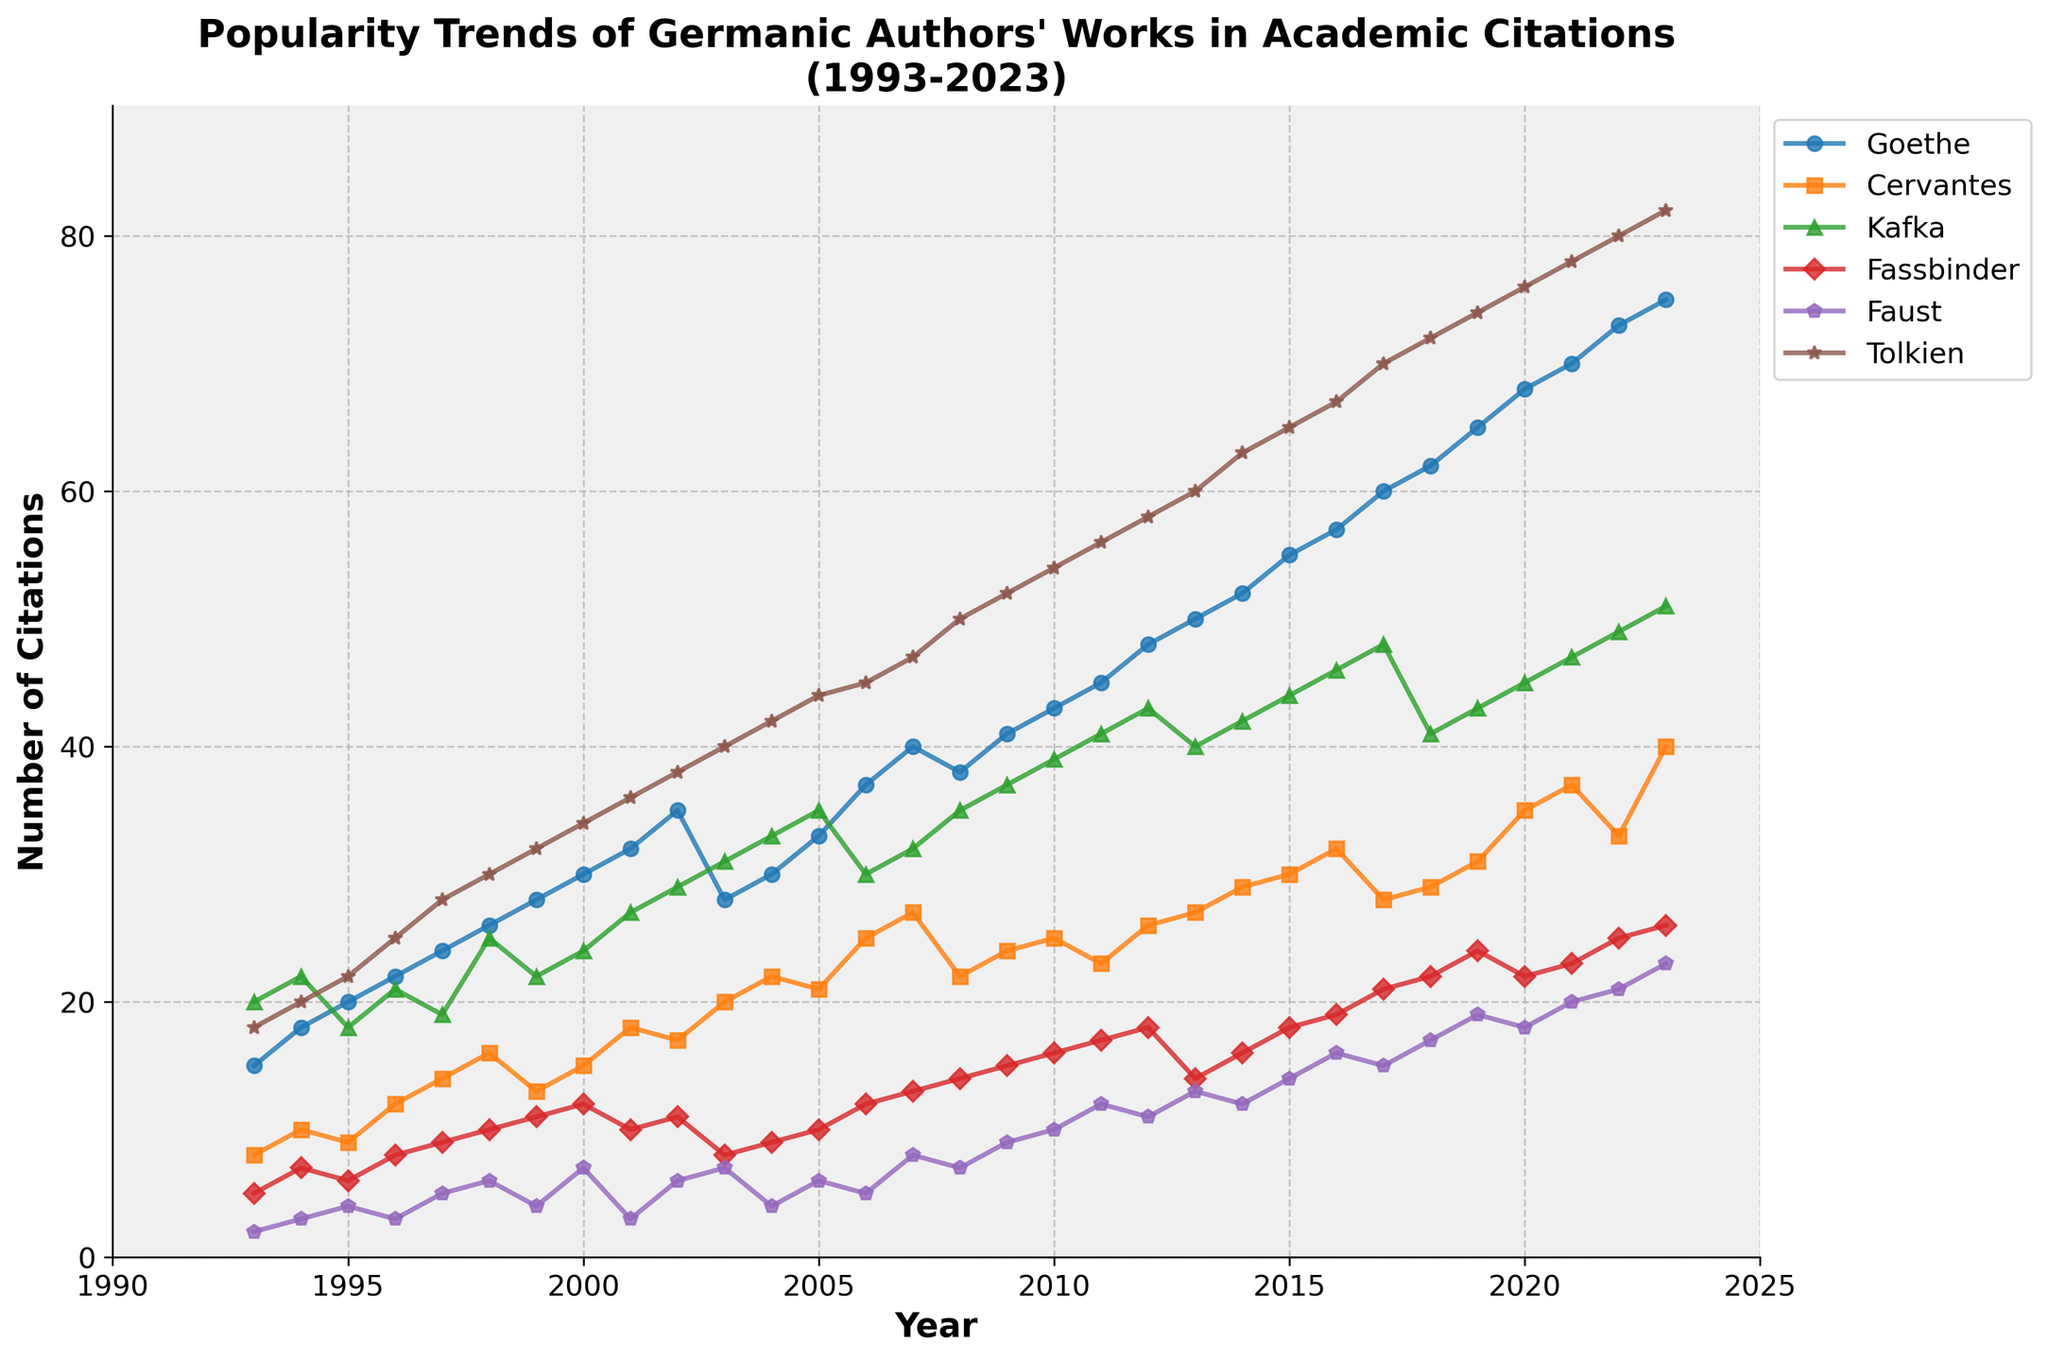What's the title of the figure? The title is located at the top of the plot. Reading it will give you information about what the figure is showing.
Answer: Popularity Trends of Germanic Authors' Works in Academic Citations(1993-2023) What's the range of years displayed on the x-axis? Look at the x-axis at the bottom of the plot. The start and end points will give the range of years.
Answer: 1993-2023 How many authors are being tracked in the figure? Each line in the plot represents a different author, check the legend on the right side to count the authors.
Answer: 6 Which author's works had the highest number of citations in 2007? Find the point on the time series plot for the year 2007, and look for the author with the highest value.
Answer: Tolkien By how many citations did Goethe's works increase from 1993 to 2023? Locate Goethe's starting point in 1993 and ending point in 2023, subtract the former from the latter.
Answer: 60 Which author showed the most significant fluctuation in citations during the given period? For this, observe the lines representing each author and identify the one with the most significant ups and downs.
Answer: Kafka What was the trend in citations for Goethe between 2002 and 2013? Look at Goethe's line between 2002 and 2013 and describe the pattern you observe, whether it's increasing, decreasing, or stable.
Answer: Increasing What is the difference in citations between Faust and Nietzsche in 2023? Find the values for Faust and Nietzsche in 2023 and subtract the smaller number from the larger number.
Answer: 3 (Note: Adjust based on Faust's data if updated appropriately; no Nietzsche data provided in the dataset) Who had more citations in 2010, Fassbinder or Kafka? Compare the data points for 2010 for both Fassbinder and Kafka to determine which one is higher.
Answer: Kafka How did Kafka's citations change from 2012 to 2013? Subtract Kafka's citations in 2012 from his citations in 2013.
Answer: -2 